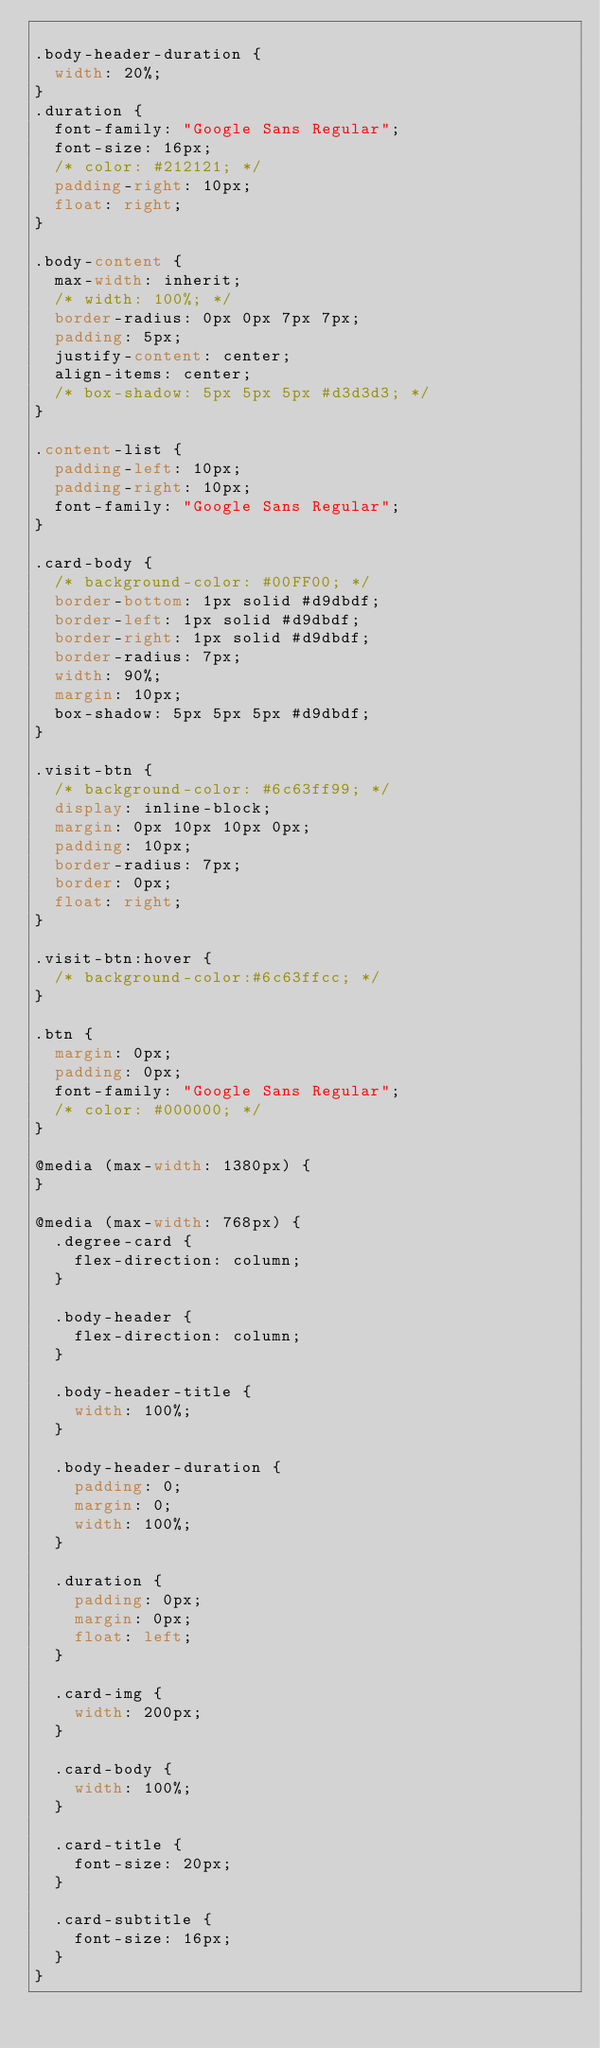Convert code to text. <code><loc_0><loc_0><loc_500><loc_500><_CSS_>
.body-header-duration {
  width: 20%;
}
.duration {
  font-family: "Google Sans Regular";
  font-size: 16px;
  /* color: #212121; */
  padding-right: 10px;
  float: right;
}

.body-content {
  max-width: inherit;
  /* width: 100%; */
  border-radius: 0px 0px 7px 7px;
  padding: 5px;
  justify-content: center;
  align-items: center;
  /* box-shadow: 5px 5px 5px #d3d3d3; */
}

.content-list {
  padding-left: 10px;
  padding-right: 10px;
  font-family: "Google Sans Regular";
}

.card-body {
  /* background-color: #00FF00; */
  border-bottom: 1px solid #d9dbdf;
  border-left: 1px solid #d9dbdf;
  border-right: 1px solid #d9dbdf;
  border-radius: 7px;
  width: 90%;
  margin: 10px;
  box-shadow: 5px 5px 5px #d9dbdf;
}

.visit-btn {
  /* background-color: #6c63ff99; */
  display: inline-block;
  margin: 0px 10px 10px 0px;
  padding: 10px;
  border-radius: 7px;
  border: 0px;
  float: right;
}

.visit-btn:hover {
  /* background-color:#6c63ffcc; */
}

.btn {
  margin: 0px;
  padding: 0px;
  font-family: "Google Sans Regular";
  /* color: #000000; */
}

@media (max-width: 1380px) {
}

@media (max-width: 768px) {
  .degree-card {
    flex-direction: column;
  }

  .body-header {
    flex-direction: column;
  }

  .body-header-title {
    width: 100%;
  }

  .body-header-duration {
    padding: 0;
    margin: 0;
    width: 100%;
  }

  .duration {
    padding: 0px;
    margin: 0px;
    float: left;
  }

  .card-img {
    width: 200px;
  }

  .card-body {
    width: 100%;
  }

  .card-title {
    font-size: 20px;
  }

  .card-subtitle {
    font-size: 16px;
  }
}
</code> 